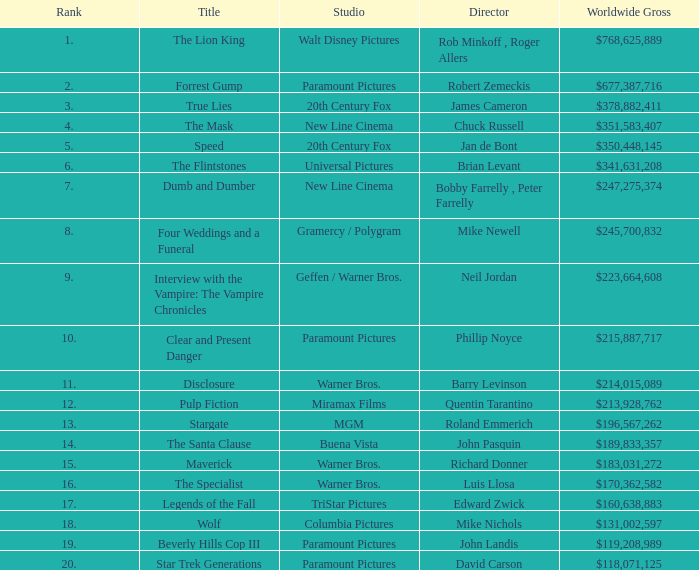What is the Title of the Film with a Rank greater than 11 and Worldwide Gross of $131,002,597? Wolf. 